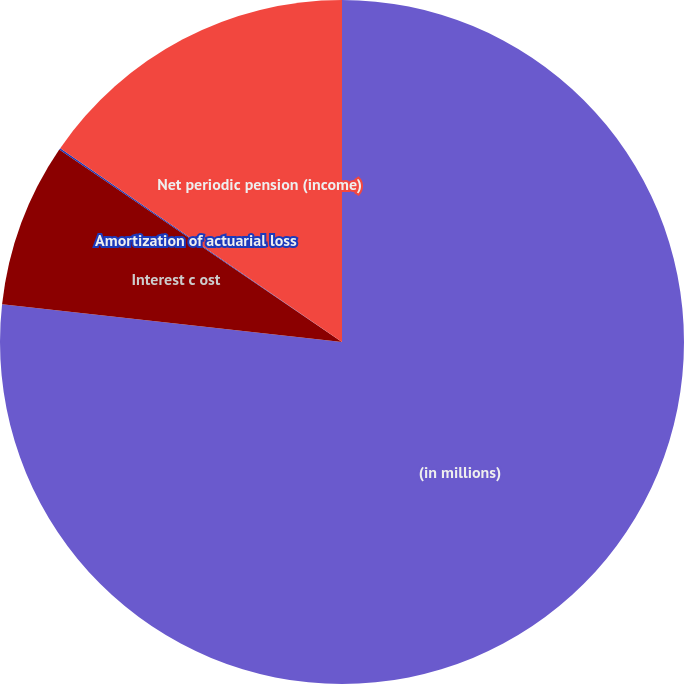Convert chart. <chart><loc_0><loc_0><loc_500><loc_500><pie_chart><fcel>(in millions)<fcel>Interest c ost<fcel>Amortization of actuarial loss<fcel>Net periodic pension (income)<nl><fcel>76.76%<fcel>7.75%<fcel>0.08%<fcel>15.41%<nl></chart> 